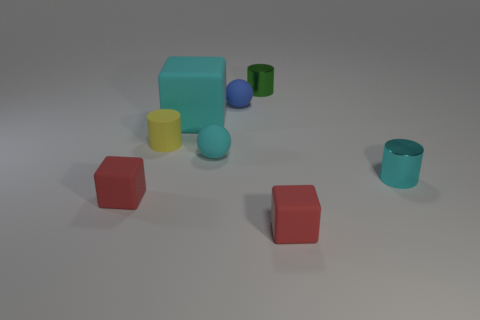What number of other objects are the same material as the tiny blue thing?
Ensure brevity in your answer.  5. What number of small cylinders are in front of the small sphere that is behind the large cyan matte object?
Make the answer very short. 2. What number of blocks are blue rubber objects or red matte objects?
Your answer should be very brief. 2. The rubber thing that is both right of the large matte thing and behind the yellow cylinder is what color?
Keep it short and to the point. Blue. Are there any other things that have the same color as the large rubber block?
Ensure brevity in your answer.  Yes. There is a ball that is in front of the cyan rubber object on the left side of the tiny cyan matte ball; what color is it?
Keep it short and to the point. Cyan. Do the cyan cube and the green cylinder have the same size?
Make the answer very short. No. Is the cylinder behind the cyan cube made of the same material as the red thing on the right side of the big cyan matte block?
Keep it short and to the point. No. What is the shape of the tiny cyan rubber thing that is right of the small matte cube on the left side of the red rubber thing to the right of the large matte object?
Offer a very short reply. Sphere. Is the number of big cyan metallic cylinders greater than the number of small yellow cylinders?
Give a very brief answer. No. 